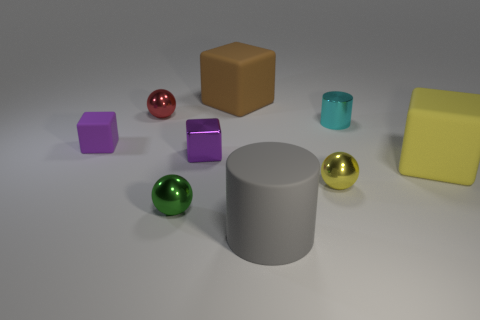Subtract all tiny green spheres. How many spheres are left? 2 Add 1 small cyan metallic objects. How many objects exist? 10 Subtract all blue balls. How many purple cubes are left? 2 Subtract all brown blocks. How many blocks are left? 3 Subtract all cylinders. How many objects are left? 7 Subtract all purple cubes. Subtract all cyan cylinders. How many cubes are left? 2 Subtract all purple metallic blocks. Subtract all green things. How many objects are left? 7 Add 9 large gray things. How many large gray things are left? 10 Add 7 purple objects. How many purple objects exist? 9 Subtract 0 yellow cylinders. How many objects are left? 9 